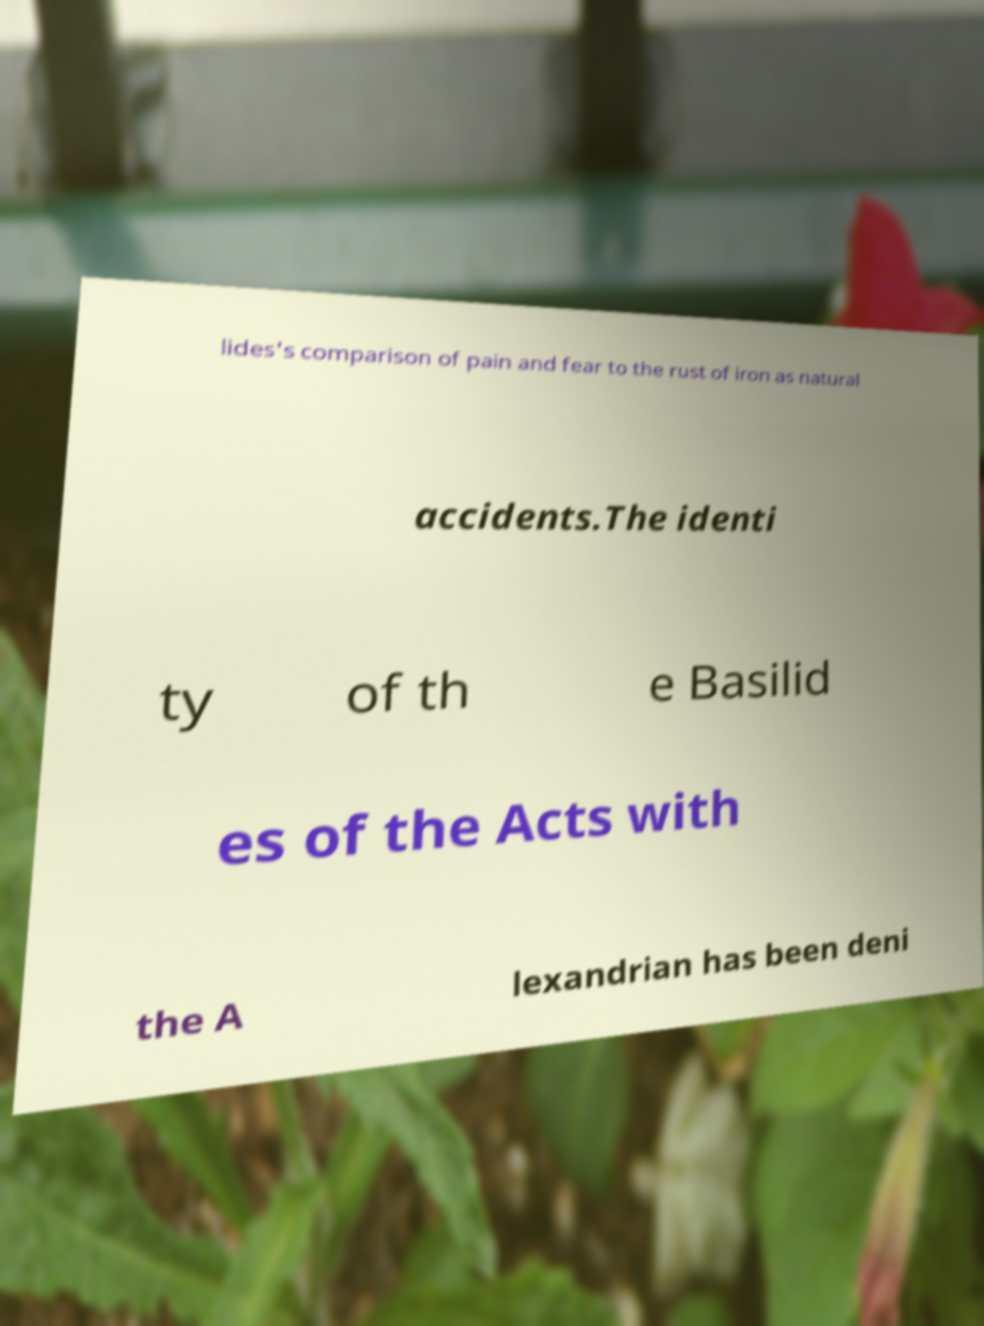Can you accurately transcribe the text from the provided image for me? lides's comparison of pain and fear to the rust of iron as natural accidents.The identi ty of th e Basilid es of the Acts with the A lexandrian has been deni 